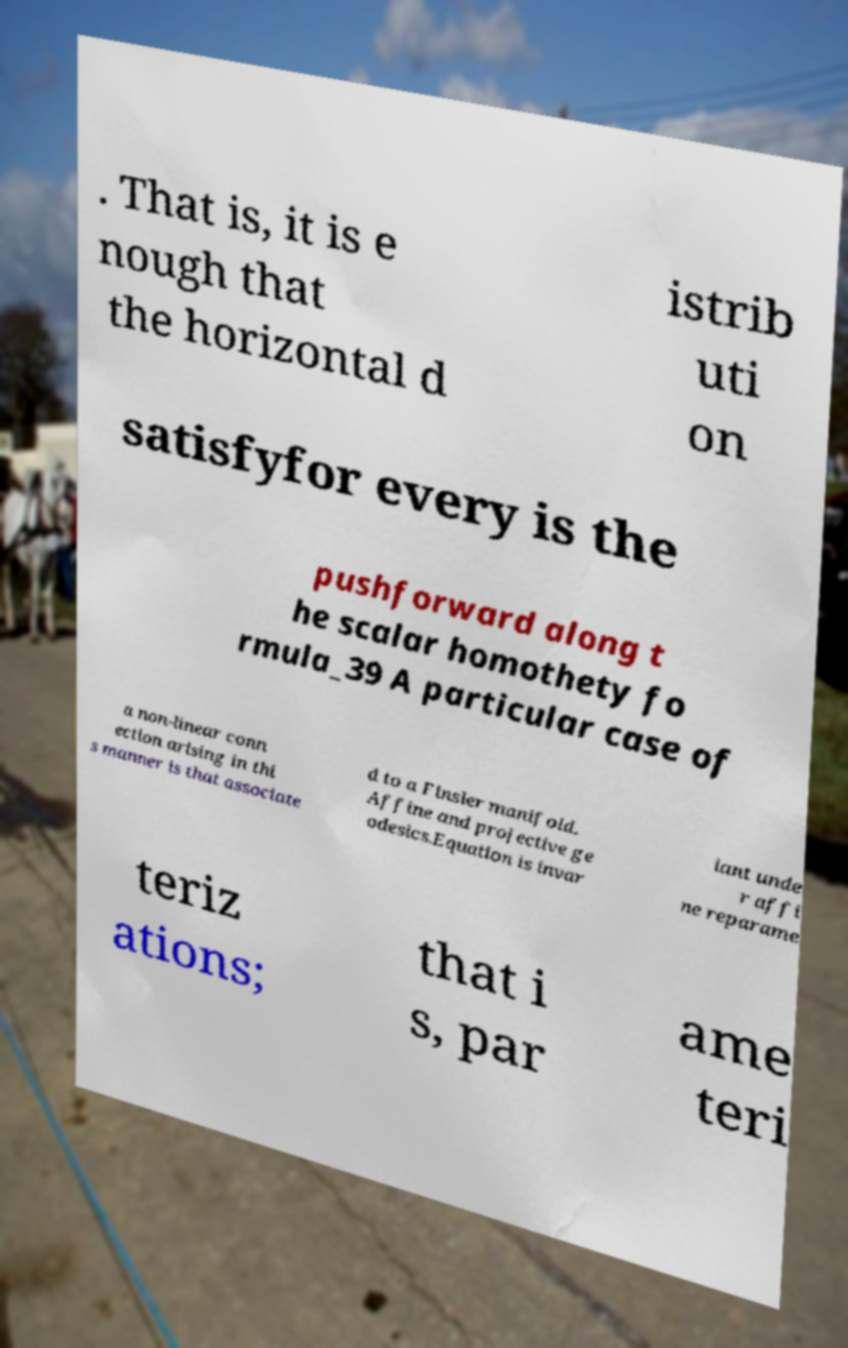For documentation purposes, I need the text within this image transcribed. Could you provide that? . That is, it is e nough that the horizontal d istrib uti on satisfyfor every is the pushforward along t he scalar homothety fo rmula_39 A particular case of a non-linear conn ection arising in thi s manner is that associate d to a Finsler manifold. Affine and projective ge odesics.Equation is invar iant unde r affi ne reparame teriz ations; that i s, par ame teri 